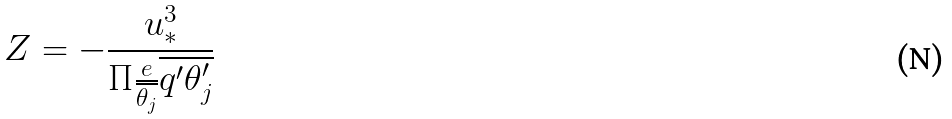<formula> <loc_0><loc_0><loc_500><loc_500>Z = - \frac { u _ { * } ^ { 3 } } { \Pi \frac { e } { \overline { \theta _ { j } } } \overline { q ^ { \prime } \theta _ { j } ^ { \prime } } }</formula> 